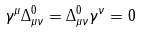<formula> <loc_0><loc_0><loc_500><loc_500>\gamma ^ { \mu } \Delta ^ { 0 } _ { \mu \nu } = \Delta ^ { 0 } _ { \mu \nu } \gamma ^ { \nu } = 0</formula> 